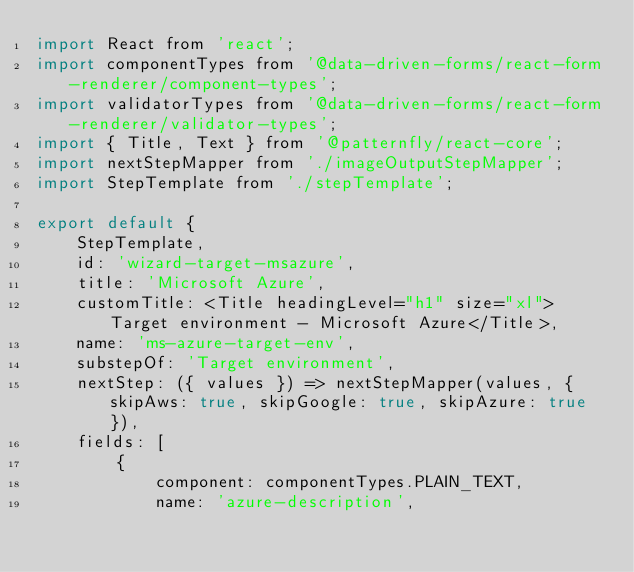Convert code to text. <code><loc_0><loc_0><loc_500><loc_500><_JavaScript_>import React from 'react';
import componentTypes from '@data-driven-forms/react-form-renderer/component-types';
import validatorTypes from '@data-driven-forms/react-form-renderer/validator-types';
import { Title, Text } from '@patternfly/react-core';
import nextStepMapper from './imageOutputStepMapper';
import StepTemplate from './stepTemplate';

export default {
    StepTemplate,
    id: 'wizard-target-msazure',
    title: 'Microsoft Azure',
    customTitle: <Title headingLevel="h1" size="xl">Target environment - Microsoft Azure</Title>,
    name: 'ms-azure-target-env',
    substepOf: 'Target environment',
    nextStep: ({ values }) => nextStepMapper(values, { skipAws: true, skipGoogle: true, skipAzure: true }),
    fields: [
        {
            component: componentTypes.PLAIN_TEXT,
            name: 'azure-description',</code> 